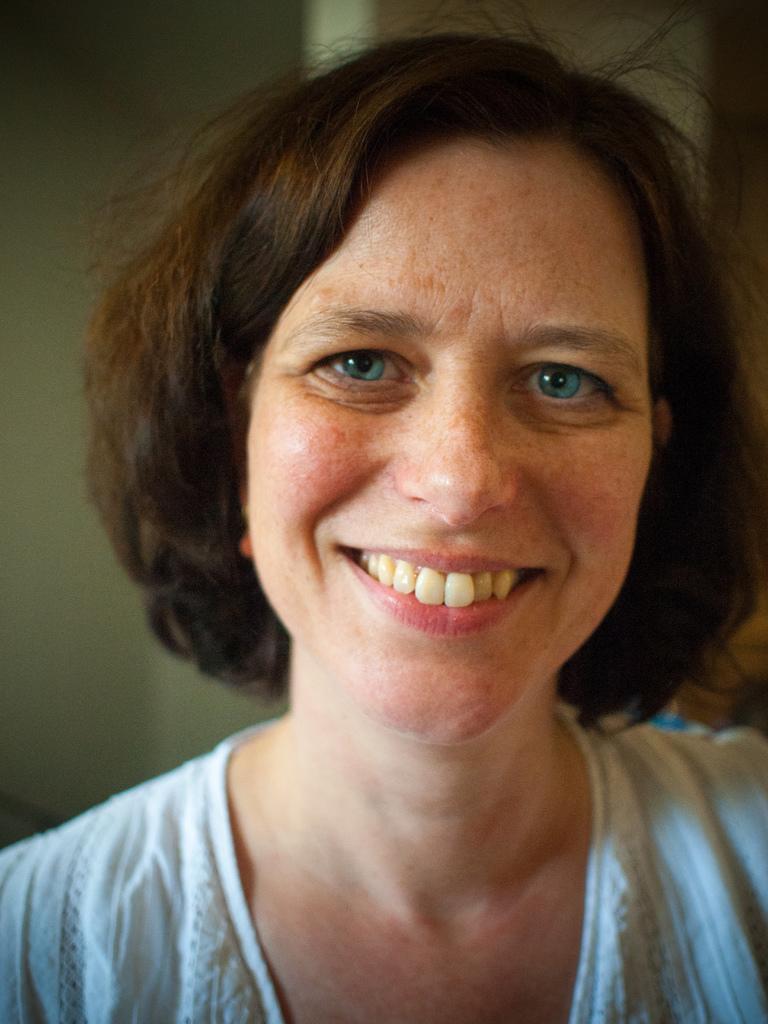Describe this image in one or two sentences. In this image, we can see there is a woman in a white color dress, smiling. And the background is blurred. 